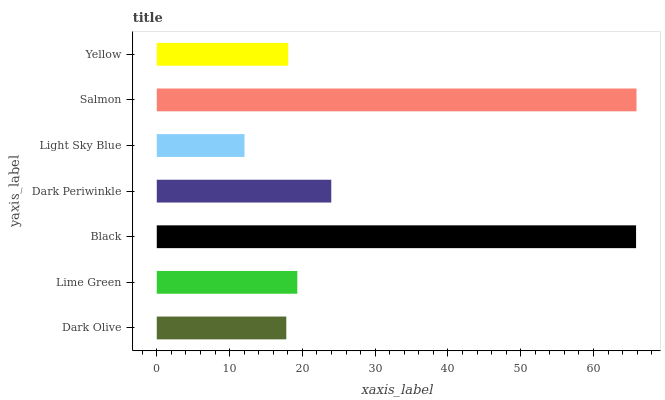Is Light Sky Blue the minimum?
Answer yes or no. Yes. Is Salmon the maximum?
Answer yes or no. Yes. Is Lime Green the minimum?
Answer yes or no. No. Is Lime Green the maximum?
Answer yes or no. No. Is Lime Green greater than Dark Olive?
Answer yes or no. Yes. Is Dark Olive less than Lime Green?
Answer yes or no. Yes. Is Dark Olive greater than Lime Green?
Answer yes or no. No. Is Lime Green less than Dark Olive?
Answer yes or no. No. Is Lime Green the high median?
Answer yes or no. Yes. Is Lime Green the low median?
Answer yes or no. Yes. Is Light Sky Blue the high median?
Answer yes or no. No. Is Salmon the low median?
Answer yes or no. No. 